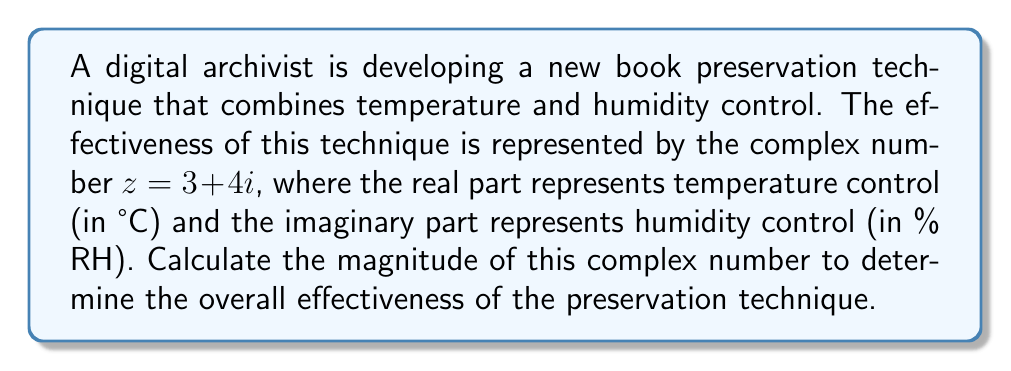What is the answer to this math problem? To find the magnitude of a complex number $z = a + bi$, we use the formula:

$$|z| = \sqrt{a^2 + b^2}$$

Where $|z|$ represents the magnitude, $a$ is the real part, and $b$ is the imaginary part.

For our complex number $z = 3 + 4i$:
$a = 3$ (temperature control)
$b = 4$ (humidity control)

Let's substitute these values into the formula:

$$|z| = \sqrt{3^2 + 4^2}$$

Simplify:
$$|z| = \sqrt{9 + 16}$$

$$|z| = \sqrt{25}$$

Calculate the square root:
$$|z| = 5$$

Therefore, the magnitude of the complex number representing the book preservation technique is 5.
Answer: $5$ 